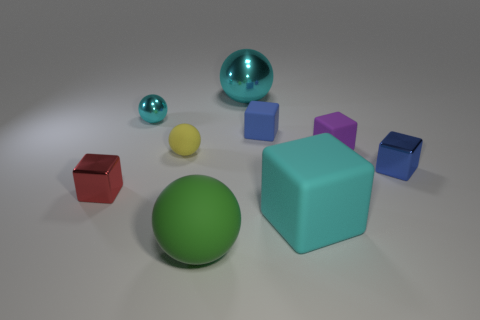The yellow thing is what shape? The yellow object in the image is a sphere. It has a smooth, rounded surface that reflects light evenly in all directions, which is characteristic of spherical objects. 